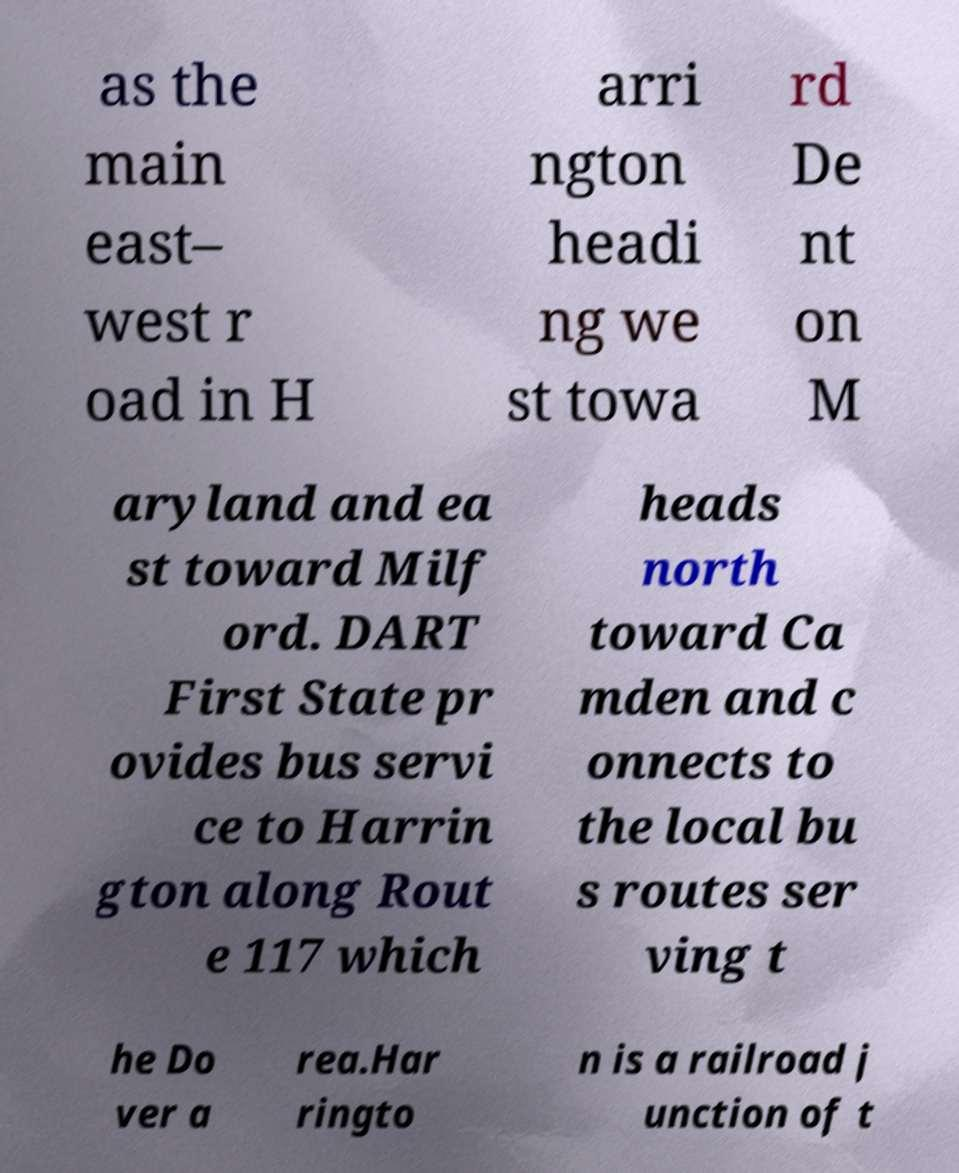Could you assist in decoding the text presented in this image and type it out clearly? as the main east– west r oad in H arri ngton headi ng we st towa rd De nt on M aryland and ea st toward Milf ord. DART First State pr ovides bus servi ce to Harrin gton along Rout e 117 which heads north toward Ca mden and c onnects to the local bu s routes ser ving t he Do ver a rea.Har ringto n is a railroad j unction of t 